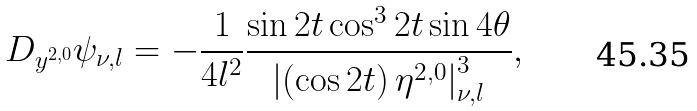Convert formula to latex. <formula><loc_0><loc_0><loc_500><loc_500>D _ { y ^ { 2 , 0 } } \psi _ { \nu , l } = - \frac { 1 } { 4 l ^ { 2 } } \frac { \sin 2 t \cos ^ { 3 } 2 t \sin 4 \theta } { \left | \left ( \cos 2 t \right ) \eta ^ { 2 , 0 } \right | _ { \nu , l } ^ { 3 } } ,</formula> 